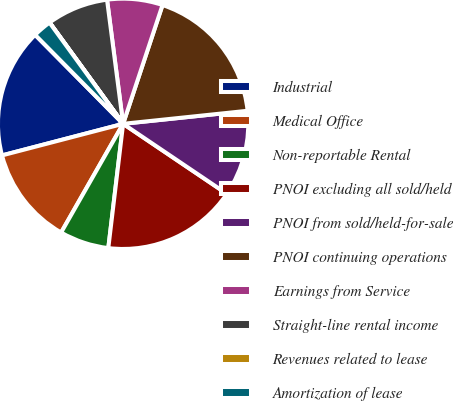<chart> <loc_0><loc_0><loc_500><loc_500><pie_chart><fcel>Industrial<fcel>Medical Office<fcel>Non-reportable Rental<fcel>PNOI excluding all sold/held<fcel>PNOI from sold/held-for-sale<fcel>PNOI continuing operations<fcel>Earnings from Service<fcel>Straight-line rental income<fcel>Revenues related to lease<fcel>Amortization of lease<nl><fcel>16.65%<fcel>12.69%<fcel>6.36%<fcel>17.44%<fcel>11.11%<fcel>18.24%<fcel>7.15%<fcel>7.94%<fcel>0.02%<fcel>2.4%<nl></chart> 